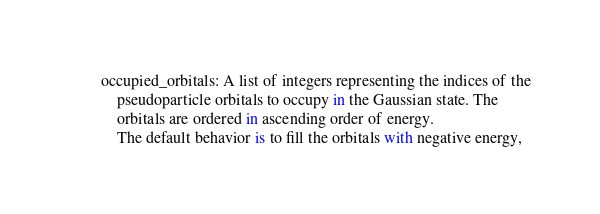Convert code to text. <code><loc_0><loc_0><loc_500><loc_500><_Python_>        occupied_orbitals: A list of integers representing the indices of the
            pseudoparticle orbitals to occupy in the Gaussian state. The
            orbitals are ordered in ascending order of energy.
            The default behavior is to fill the orbitals with negative energy,</code> 